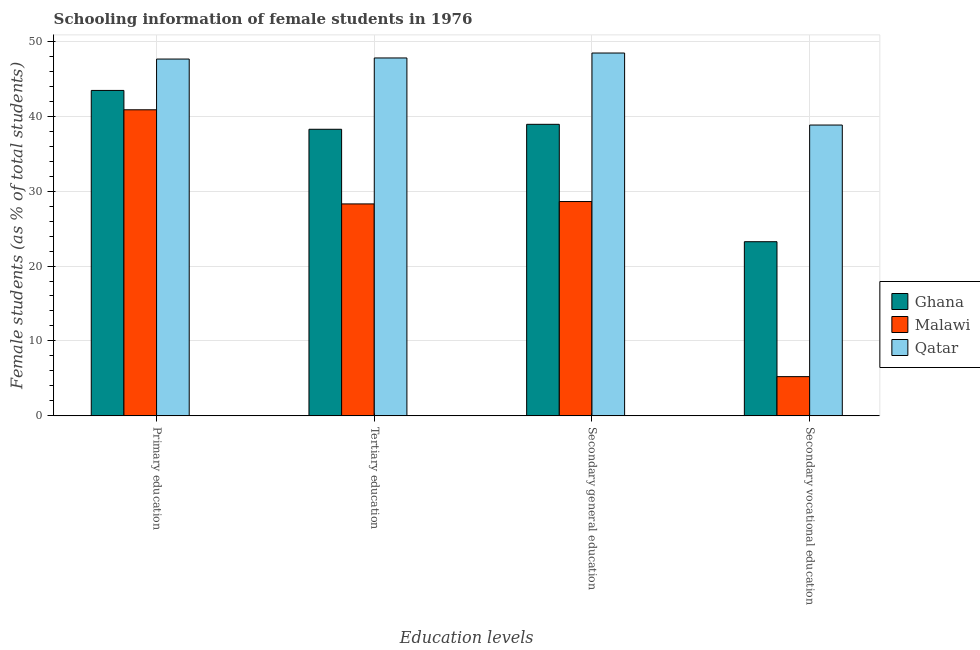How many groups of bars are there?
Give a very brief answer. 4. Are the number of bars per tick equal to the number of legend labels?
Provide a short and direct response. Yes. Are the number of bars on each tick of the X-axis equal?
Give a very brief answer. Yes. How many bars are there on the 4th tick from the right?
Make the answer very short. 3. What is the label of the 1st group of bars from the left?
Make the answer very short. Primary education. What is the percentage of female students in primary education in Ghana?
Provide a succinct answer. 43.44. Across all countries, what is the maximum percentage of female students in secondary vocational education?
Provide a succinct answer. 38.82. Across all countries, what is the minimum percentage of female students in primary education?
Offer a very short reply. 40.85. In which country was the percentage of female students in secondary education maximum?
Offer a terse response. Qatar. In which country was the percentage of female students in secondary education minimum?
Give a very brief answer. Malawi. What is the total percentage of female students in secondary vocational education in the graph?
Keep it short and to the point. 67.3. What is the difference between the percentage of female students in secondary vocational education in Malawi and that in Ghana?
Offer a terse response. -18.01. What is the difference between the percentage of female students in secondary vocational education in Malawi and the percentage of female students in primary education in Ghana?
Provide a short and direct response. -38.2. What is the average percentage of female students in secondary vocational education per country?
Keep it short and to the point. 22.43. What is the difference between the percentage of female students in primary education and percentage of female students in secondary education in Qatar?
Offer a terse response. -0.81. In how many countries, is the percentage of female students in tertiary education greater than 38 %?
Keep it short and to the point. 2. What is the ratio of the percentage of female students in tertiary education in Qatar to that in Malawi?
Provide a succinct answer. 1.69. Is the percentage of female students in secondary vocational education in Malawi less than that in Qatar?
Give a very brief answer. Yes. What is the difference between the highest and the second highest percentage of female students in secondary education?
Give a very brief answer. 9.52. What is the difference between the highest and the lowest percentage of female students in secondary education?
Ensure brevity in your answer.  19.82. In how many countries, is the percentage of female students in secondary education greater than the average percentage of female students in secondary education taken over all countries?
Provide a short and direct response. 2. Is it the case that in every country, the sum of the percentage of female students in tertiary education and percentage of female students in secondary education is greater than the sum of percentage of female students in secondary vocational education and percentage of female students in primary education?
Provide a short and direct response. No. What does the 2nd bar from the left in Primary education represents?
Your answer should be very brief. Malawi. What does the 2nd bar from the right in Secondary general education represents?
Your response must be concise. Malawi. Is it the case that in every country, the sum of the percentage of female students in primary education and percentage of female students in tertiary education is greater than the percentage of female students in secondary education?
Ensure brevity in your answer.  Yes. Are all the bars in the graph horizontal?
Your response must be concise. No. Does the graph contain any zero values?
Your response must be concise. No. What is the title of the graph?
Provide a short and direct response. Schooling information of female students in 1976. What is the label or title of the X-axis?
Make the answer very short. Education levels. What is the label or title of the Y-axis?
Ensure brevity in your answer.  Female students (as % of total students). What is the Female students (as % of total students) of Ghana in Primary education?
Your response must be concise. 43.44. What is the Female students (as % of total students) of Malawi in Primary education?
Your answer should be very brief. 40.85. What is the Female students (as % of total students) of Qatar in Primary education?
Offer a terse response. 47.62. What is the Female students (as % of total students) in Ghana in Tertiary education?
Your answer should be compact. 38.25. What is the Female students (as % of total students) in Malawi in Tertiary education?
Offer a terse response. 28.29. What is the Female students (as % of total students) of Qatar in Tertiary education?
Make the answer very short. 47.77. What is the Female students (as % of total students) in Ghana in Secondary general education?
Your answer should be compact. 38.91. What is the Female students (as % of total students) of Malawi in Secondary general education?
Your answer should be compact. 28.61. What is the Female students (as % of total students) in Qatar in Secondary general education?
Your response must be concise. 48.43. What is the Female students (as % of total students) of Ghana in Secondary vocational education?
Offer a terse response. 23.24. What is the Female students (as % of total students) of Malawi in Secondary vocational education?
Ensure brevity in your answer.  5.24. What is the Female students (as % of total students) of Qatar in Secondary vocational education?
Provide a succinct answer. 38.82. Across all Education levels, what is the maximum Female students (as % of total students) of Ghana?
Offer a terse response. 43.44. Across all Education levels, what is the maximum Female students (as % of total students) of Malawi?
Provide a succinct answer. 40.85. Across all Education levels, what is the maximum Female students (as % of total students) in Qatar?
Your response must be concise. 48.43. Across all Education levels, what is the minimum Female students (as % of total students) of Ghana?
Ensure brevity in your answer.  23.24. Across all Education levels, what is the minimum Female students (as % of total students) of Malawi?
Provide a succinct answer. 5.24. Across all Education levels, what is the minimum Female students (as % of total students) in Qatar?
Provide a succinct answer. 38.82. What is the total Female students (as % of total students) in Ghana in the graph?
Your answer should be very brief. 143.84. What is the total Female students (as % of total students) in Malawi in the graph?
Ensure brevity in your answer.  102.98. What is the total Female students (as % of total students) of Qatar in the graph?
Give a very brief answer. 182.64. What is the difference between the Female students (as % of total students) of Ghana in Primary education and that in Tertiary education?
Your response must be concise. 5.18. What is the difference between the Female students (as % of total students) in Malawi in Primary education and that in Tertiary education?
Offer a terse response. 12.56. What is the difference between the Female students (as % of total students) of Qatar in Primary education and that in Tertiary education?
Your response must be concise. -0.15. What is the difference between the Female students (as % of total students) of Ghana in Primary education and that in Secondary general education?
Ensure brevity in your answer.  4.52. What is the difference between the Female students (as % of total students) in Malawi in Primary education and that in Secondary general education?
Provide a succinct answer. 12.25. What is the difference between the Female students (as % of total students) of Qatar in Primary education and that in Secondary general education?
Your response must be concise. -0.81. What is the difference between the Female students (as % of total students) of Ghana in Primary education and that in Secondary vocational education?
Provide a succinct answer. 20.19. What is the difference between the Female students (as % of total students) of Malawi in Primary education and that in Secondary vocational education?
Make the answer very short. 35.62. What is the difference between the Female students (as % of total students) in Qatar in Primary education and that in Secondary vocational education?
Your answer should be very brief. 8.81. What is the difference between the Female students (as % of total students) in Ghana in Tertiary education and that in Secondary general education?
Offer a very short reply. -0.66. What is the difference between the Female students (as % of total students) in Malawi in Tertiary education and that in Secondary general education?
Your answer should be very brief. -0.32. What is the difference between the Female students (as % of total students) in Qatar in Tertiary education and that in Secondary general education?
Make the answer very short. -0.66. What is the difference between the Female students (as % of total students) of Ghana in Tertiary education and that in Secondary vocational education?
Offer a very short reply. 15.01. What is the difference between the Female students (as % of total students) in Malawi in Tertiary education and that in Secondary vocational education?
Your answer should be very brief. 23.05. What is the difference between the Female students (as % of total students) of Qatar in Tertiary education and that in Secondary vocational education?
Your answer should be compact. 8.95. What is the difference between the Female students (as % of total students) of Ghana in Secondary general education and that in Secondary vocational education?
Your answer should be very brief. 15.67. What is the difference between the Female students (as % of total students) of Malawi in Secondary general education and that in Secondary vocational education?
Give a very brief answer. 23.37. What is the difference between the Female students (as % of total students) in Qatar in Secondary general education and that in Secondary vocational education?
Offer a very short reply. 9.61. What is the difference between the Female students (as % of total students) of Ghana in Primary education and the Female students (as % of total students) of Malawi in Tertiary education?
Ensure brevity in your answer.  15.15. What is the difference between the Female students (as % of total students) of Ghana in Primary education and the Female students (as % of total students) of Qatar in Tertiary education?
Your answer should be compact. -4.33. What is the difference between the Female students (as % of total students) in Malawi in Primary education and the Female students (as % of total students) in Qatar in Tertiary education?
Your answer should be very brief. -6.92. What is the difference between the Female students (as % of total students) of Ghana in Primary education and the Female students (as % of total students) of Malawi in Secondary general education?
Ensure brevity in your answer.  14.83. What is the difference between the Female students (as % of total students) in Ghana in Primary education and the Female students (as % of total students) in Qatar in Secondary general education?
Provide a succinct answer. -4.99. What is the difference between the Female students (as % of total students) of Malawi in Primary education and the Female students (as % of total students) of Qatar in Secondary general education?
Your answer should be very brief. -7.58. What is the difference between the Female students (as % of total students) in Ghana in Primary education and the Female students (as % of total students) in Malawi in Secondary vocational education?
Provide a short and direct response. 38.2. What is the difference between the Female students (as % of total students) of Ghana in Primary education and the Female students (as % of total students) of Qatar in Secondary vocational education?
Keep it short and to the point. 4.62. What is the difference between the Female students (as % of total students) of Malawi in Primary education and the Female students (as % of total students) of Qatar in Secondary vocational education?
Make the answer very short. 2.03. What is the difference between the Female students (as % of total students) of Ghana in Tertiary education and the Female students (as % of total students) of Malawi in Secondary general education?
Offer a terse response. 9.65. What is the difference between the Female students (as % of total students) in Ghana in Tertiary education and the Female students (as % of total students) in Qatar in Secondary general education?
Ensure brevity in your answer.  -10.18. What is the difference between the Female students (as % of total students) of Malawi in Tertiary education and the Female students (as % of total students) of Qatar in Secondary general education?
Your response must be concise. -20.14. What is the difference between the Female students (as % of total students) of Ghana in Tertiary education and the Female students (as % of total students) of Malawi in Secondary vocational education?
Offer a terse response. 33.01. What is the difference between the Female students (as % of total students) in Ghana in Tertiary education and the Female students (as % of total students) in Qatar in Secondary vocational education?
Your answer should be very brief. -0.57. What is the difference between the Female students (as % of total students) of Malawi in Tertiary education and the Female students (as % of total students) of Qatar in Secondary vocational education?
Make the answer very short. -10.53. What is the difference between the Female students (as % of total students) in Ghana in Secondary general education and the Female students (as % of total students) in Malawi in Secondary vocational education?
Offer a terse response. 33.68. What is the difference between the Female students (as % of total students) of Ghana in Secondary general education and the Female students (as % of total students) of Qatar in Secondary vocational education?
Offer a very short reply. 0.1. What is the difference between the Female students (as % of total students) of Malawi in Secondary general education and the Female students (as % of total students) of Qatar in Secondary vocational education?
Provide a succinct answer. -10.21. What is the average Female students (as % of total students) in Ghana per Education levels?
Ensure brevity in your answer.  35.96. What is the average Female students (as % of total students) of Malawi per Education levels?
Your answer should be compact. 25.75. What is the average Female students (as % of total students) in Qatar per Education levels?
Provide a short and direct response. 45.66. What is the difference between the Female students (as % of total students) of Ghana and Female students (as % of total students) of Malawi in Primary education?
Ensure brevity in your answer.  2.58. What is the difference between the Female students (as % of total students) in Ghana and Female students (as % of total students) in Qatar in Primary education?
Your answer should be compact. -4.19. What is the difference between the Female students (as % of total students) of Malawi and Female students (as % of total students) of Qatar in Primary education?
Provide a short and direct response. -6.77. What is the difference between the Female students (as % of total students) in Ghana and Female students (as % of total students) in Malawi in Tertiary education?
Keep it short and to the point. 9.96. What is the difference between the Female students (as % of total students) of Ghana and Female students (as % of total students) of Qatar in Tertiary education?
Offer a terse response. -9.52. What is the difference between the Female students (as % of total students) of Malawi and Female students (as % of total students) of Qatar in Tertiary education?
Keep it short and to the point. -19.48. What is the difference between the Female students (as % of total students) in Ghana and Female students (as % of total students) in Malawi in Secondary general education?
Offer a terse response. 10.31. What is the difference between the Female students (as % of total students) in Ghana and Female students (as % of total students) in Qatar in Secondary general education?
Keep it short and to the point. -9.52. What is the difference between the Female students (as % of total students) of Malawi and Female students (as % of total students) of Qatar in Secondary general education?
Make the answer very short. -19.82. What is the difference between the Female students (as % of total students) of Ghana and Female students (as % of total students) of Malawi in Secondary vocational education?
Make the answer very short. 18.01. What is the difference between the Female students (as % of total students) in Ghana and Female students (as % of total students) in Qatar in Secondary vocational education?
Your answer should be very brief. -15.57. What is the difference between the Female students (as % of total students) of Malawi and Female students (as % of total students) of Qatar in Secondary vocational education?
Your answer should be very brief. -33.58. What is the ratio of the Female students (as % of total students) in Ghana in Primary education to that in Tertiary education?
Ensure brevity in your answer.  1.14. What is the ratio of the Female students (as % of total students) in Malawi in Primary education to that in Tertiary education?
Offer a terse response. 1.44. What is the ratio of the Female students (as % of total students) in Qatar in Primary education to that in Tertiary education?
Your answer should be very brief. 1. What is the ratio of the Female students (as % of total students) of Ghana in Primary education to that in Secondary general education?
Your response must be concise. 1.12. What is the ratio of the Female students (as % of total students) in Malawi in Primary education to that in Secondary general education?
Your response must be concise. 1.43. What is the ratio of the Female students (as % of total students) in Qatar in Primary education to that in Secondary general education?
Make the answer very short. 0.98. What is the ratio of the Female students (as % of total students) of Ghana in Primary education to that in Secondary vocational education?
Your response must be concise. 1.87. What is the ratio of the Female students (as % of total students) of Malawi in Primary education to that in Secondary vocational education?
Your response must be concise. 7.8. What is the ratio of the Female students (as % of total students) of Qatar in Primary education to that in Secondary vocational education?
Make the answer very short. 1.23. What is the ratio of the Female students (as % of total students) in Malawi in Tertiary education to that in Secondary general education?
Your answer should be very brief. 0.99. What is the ratio of the Female students (as % of total students) in Qatar in Tertiary education to that in Secondary general education?
Offer a terse response. 0.99. What is the ratio of the Female students (as % of total students) of Ghana in Tertiary education to that in Secondary vocational education?
Provide a succinct answer. 1.65. What is the ratio of the Female students (as % of total students) of Malawi in Tertiary education to that in Secondary vocational education?
Your answer should be compact. 5.4. What is the ratio of the Female students (as % of total students) of Qatar in Tertiary education to that in Secondary vocational education?
Provide a short and direct response. 1.23. What is the ratio of the Female students (as % of total students) of Ghana in Secondary general education to that in Secondary vocational education?
Provide a succinct answer. 1.67. What is the ratio of the Female students (as % of total students) of Malawi in Secondary general education to that in Secondary vocational education?
Provide a succinct answer. 5.46. What is the ratio of the Female students (as % of total students) in Qatar in Secondary general education to that in Secondary vocational education?
Your answer should be compact. 1.25. What is the difference between the highest and the second highest Female students (as % of total students) of Ghana?
Your answer should be very brief. 4.52. What is the difference between the highest and the second highest Female students (as % of total students) of Malawi?
Provide a succinct answer. 12.25. What is the difference between the highest and the second highest Female students (as % of total students) of Qatar?
Provide a succinct answer. 0.66. What is the difference between the highest and the lowest Female students (as % of total students) of Ghana?
Your response must be concise. 20.19. What is the difference between the highest and the lowest Female students (as % of total students) of Malawi?
Give a very brief answer. 35.62. What is the difference between the highest and the lowest Female students (as % of total students) of Qatar?
Provide a succinct answer. 9.61. 